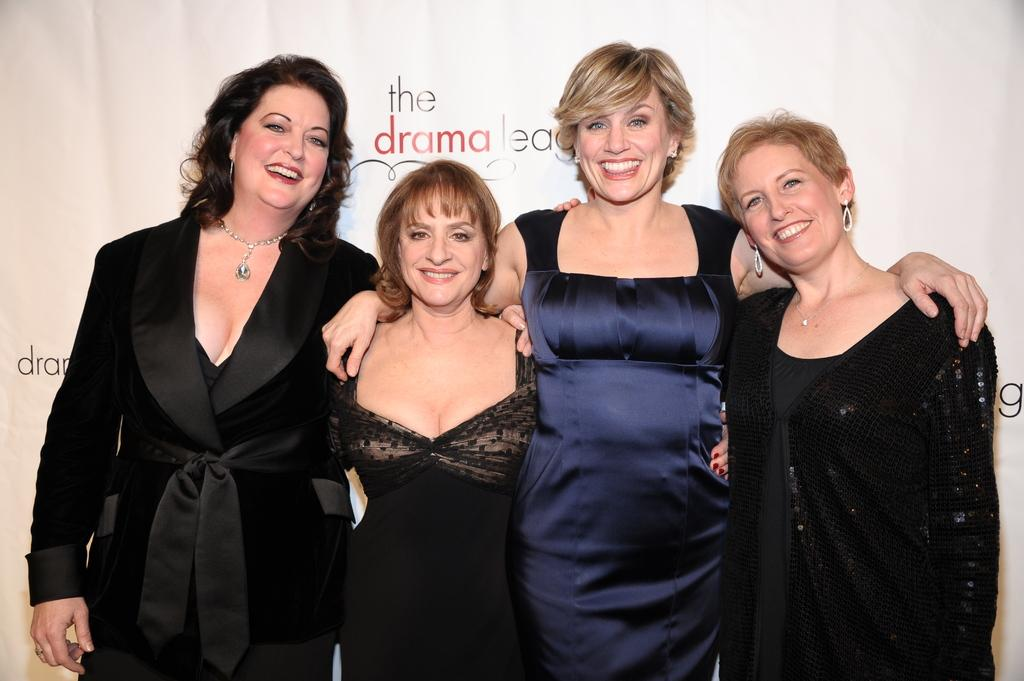How many people are in the image? There are four women in the image. What are the women doing in the image? The women are standing and smiling. What can be seen behind the women in the image? There is a banner visible behind the women. What type of sheet is being used by the son in the image? There is no son present in the image, and therefore no sheet can be associated with him. 